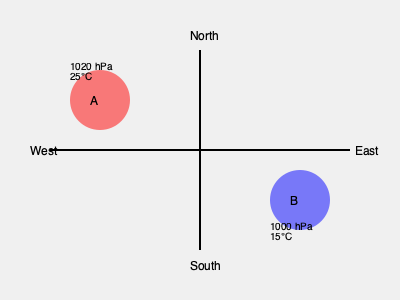Based on the temperature and pressure data provided on the map, which type of weather front should be placed between points A and B, and in which direction is it moving? To determine the type of weather front and its direction, we need to analyze the temperature and pressure differences between points A and B:

1. Temperature analysis:
   - Point A: 25°C
   - Point B: 15°C
   The temperature decreases from A to B, indicating a cold front.

2. Pressure analysis:
   - Point A: 1020 hPa
   - Point B: 1000 hPa
   The pressure decreases from A to B, which is consistent with a cold front.

3. Front characteristics:
   - Cold fronts are characterized by a decrease in temperature and pressure.
   - They typically move from higher pressure to lower pressure areas.

4. Direction of movement:
   - The front would move from point A (higher pressure) towards point B (lower pressure).
   - On the map, this corresponds to a movement from northwest to southeast.

5. Representation:
   - Cold fronts are typically represented by a blue line with triangles pointing in the direction of movement.

Therefore, a cold front should be placed between points A and B, moving from northwest to southeast.
Answer: Cold front moving southeast 